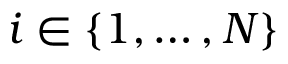<formula> <loc_0><loc_0><loc_500><loc_500>i \in \{ 1 , \dots , N \}</formula> 